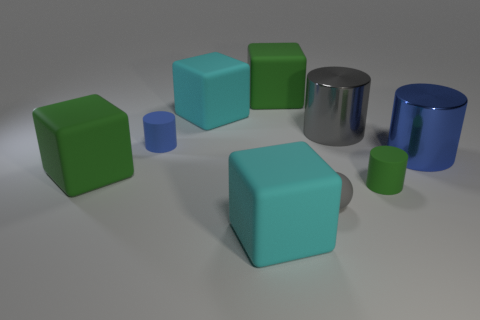What number of cyan objects are either rubber cubes or rubber balls? There are three cyan objects in the image, which include two rubber cubes with a slightly matte surface texture and one rubber ball. Their cyan color is distinct and provides a visual contrast with the green cubes and blue cylinders and ball, helping them stand out within the scene. 